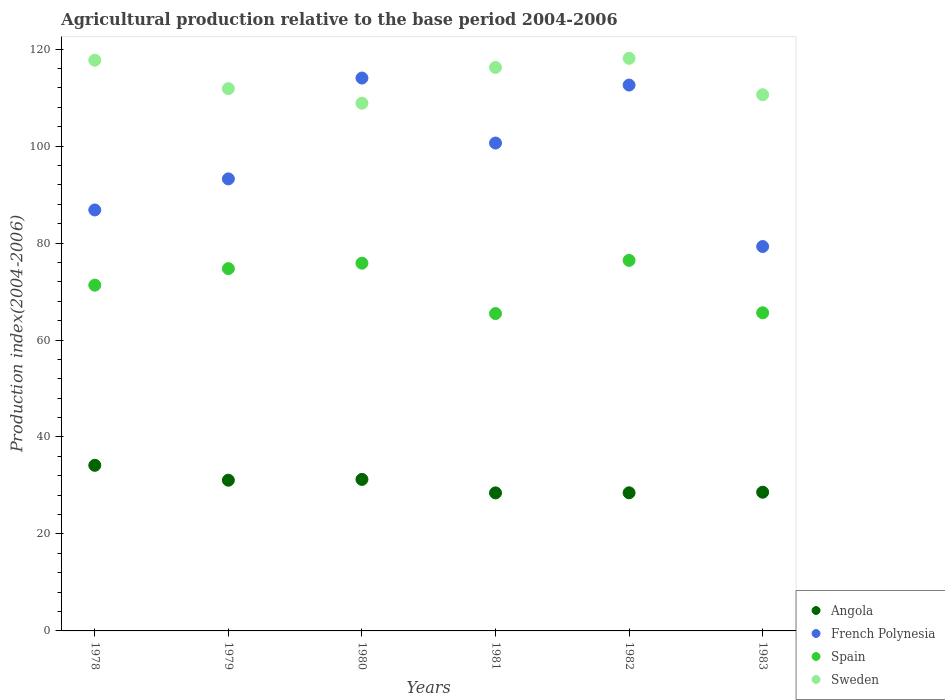Is the number of dotlines equal to the number of legend labels?
Offer a very short reply. Yes. What is the agricultural production index in Spain in 1983?
Your answer should be very brief. 65.62. Across all years, what is the maximum agricultural production index in French Polynesia?
Give a very brief answer. 114.04. Across all years, what is the minimum agricultural production index in French Polynesia?
Offer a terse response. 79.29. What is the total agricultural production index in Sweden in the graph?
Offer a terse response. 683.36. What is the difference between the agricultural production index in French Polynesia in 1978 and that in 1980?
Offer a terse response. -27.21. What is the difference between the agricultural production index in French Polynesia in 1979 and the agricultural production index in Sweden in 1981?
Make the answer very short. -22.99. What is the average agricultural production index in French Polynesia per year?
Ensure brevity in your answer.  97.77. In the year 1978, what is the difference between the agricultural production index in Angola and agricultural production index in Sweden?
Provide a succinct answer. -83.56. In how many years, is the agricultural production index in Sweden greater than 8?
Your answer should be compact. 6. What is the ratio of the agricultural production index in Sweden in 1980 to that in 1983?
Make the answer very short. 0.98. What is the difference between the highest and the second highest agricultural production index in French Polynesia?
Offer a terse response. 1.45. What is the difference between the highest and the lowest agricultural production index in Sweden?
Keep it short and to the point. 9.26. In how many years, is the agricultural production index in Angola greater than the average agricultural production index in Angola taken over all years?
Your response must be concise. 3. Does the agricultural production index in Angola monotonically increase over the years?
Your response must be concise. No. How many dotlines are there?
Keep it short and to the point. 4. How many years are there in the graph?
Ensure brevity in your answer.  6. What is the difference between two consecutive major ticks on the Y-axis?
Keep it short and to the point. 20. Does the graph contain grids?
Your answer should be very brief. No. How many legend labels are there?
Provide a short and direct response. 4. How are the legend labels stacked?
Offer a very short reply. Vertical. What is the title of the graph?
Give a very brief answer. Agricultural production relative to the base period 2004-2006. Does "South Sudan" appear as one of the legend labels in the graph?
Ensure brevity in your answer.  No. What is the label or title of the X-axis?
Give a very brief answer. Years. What is the label or title of the Y-axis?
Ensure brevity in your answer.  Production index(2004-2006). What is the Production index(2004-2006) in Angola in 1978?
Offer a very short reply. 34.16. What is the Production index(2004-2006) in French Polynesia in 1978?
Your response must be concise. 86.83. What is the Production index(2004-2006) of Spain in 1978?
Your response must be concise. 71.32. What is the Production index(2004-2006) of Sweden in 1978?
Your response must be concise. 117.72. What is the Production index(2004-2006) of Angola in 1979?
Your answer should be compact. 31.09. What is the Production index(2004-2006) of French Polynesia in 1979?
Give a very brief answer. 93.24. What is the Production index(2004-2006) of Spain in 1979?
Your response must be concise. 74.73. What is the Production index(2004-2006) of Sweden in 1979?
Keep it short and to the point. 111.85. What is the Production index(2004-2006) in Angola in 1980?
Give a very brief answer. 31.25. What is the Production index(2004-2006) of French Polynesia in 1980?
Your response must be concise. 114.04. What is the Production index(2004-2006) of Spain in 1980?
Keep it short and to the point. 75.85. What is the Production index(2004-2006) in Sweden in 1980?
Your response must be concise. 108.85. What is the Production index(2004-2006) of Angola in 1981?
Offer a terse response. 28.47. What is the Production index(2004-2006) in French Polynesia in 1981?
Make the answer very short. 100.63. What is the Production index(2004-2006) of Spain in 1981?
Give a very brief answer. 65.46. What is the Production index(2004-2006) of Sweden in 1981?
Ensure brevity in your answer.  116.23. What is the Production index(2004-2006) of Angola in 1982?
Provide a short and direct response. 28.49. What is the Production index(2004-2006) in French Polynesia in 1982?
Your answer should be compact. 112.59. What is the Production index(2004-2006) in Spain in 1982?
Provide a succinct answer. 76.43. What is the Production index(2004-2006) in Sweden in 1982?
Make the answer very short. 118.11. What is the Production index(2004-2006) in Angola in 1983?
Your response must be concise. 28.61. What is the Production index(2004-2006) of French Polynesia in 1983?
Give a very brief answer. 79.29. What is the Production index(2004-2006) of Spain in 1983?
Offer a very short reply. 65.62. What is the Production index(2004-2006) in Sweden in 1983?
Ensure brevity in your answer.  110.6. Across all years, what is the maximum Production index(2004-2006) of Angola?
Offer a very short reply. 34.16. Across all years, what is the maximum Production index(2004-2006) in French Polynesia?
Keep it short and to the point. 114.04. Across all years, what is the maximum Production index(2004-2006) in Spain?
Provide a succinct answer. 76.43. Across all years, what is the maximum Production index(2004-2006) in Sweden?
Ensure brevity in your answer.  118.11. Across all years, what is the minimum Production index(2004-2006) of Angola?
Make the answer very short. 28.47. Across all years, what is the minimum Production index(2004-2006) in French Polynesia?
Offer a very short reply. 79.29. Across all years, what is the minimum Production index(2004-2006) in Spain?
Make the answer very short. 65.46. Across all years, what is the minimum Production index(2004-2006) of Sweden?
Make the answer very short. 108.85. What is the total Production index(2004-2006) of Angola in the graph?
Give a very brief answer. 182.07. What is the total Production index(2004-2006) of French Polynesia in the graph?
Offer a very short reply. 586.62. What is the total Production index(2004-2006) of Spain in the graph?
Your response must be concise. 429.41. What is the total Production index(2004-2006) of Sweden in the graph?
Offer a very short reply. 683.36. What is the difference between the Production index(2004-2006) of Angola in 1978 and that in 1979?
Make the answer very short. 3.07. What is the difference between the Production index(2004-2006) in French Polynesia in 1978 and that in 1979?
Your response must be concise. -6.41. What is the difference between the Production index(2004-2006) in Spain in 1978 and that in 1979?
Offer a very short reply. -3.41. What is the difference between the Production index(2004-2006) of Sweden in 1978 and that in 1979?
Offer a very short reply. 5.87. What is the difference between the Production index(2004-2006) in Angola in 1978 and that in 1980?
Your response must be concise. 2.91. What is the difference between the Production index(2004-2006) in French Polynesia in 1978 and that in 1980?
Offer a terse response. -27.21. What is the difference between the Production index(2004-2006) in Spain in 1978 and that in 1980?
Give a very brief answer. -4.53. What is the difference between the Production index(2004-2006) in Sweden in 1978 and that in 1980?
Your response must be concise. 8.87. What is the difference between the Production index(2004-2006) in Angola in 1978 and that in 1981?
Keep it short and to the point. 5.69. What is the difference between the Production index(2004-2006) of French Polynesia in 1978 and that in 1981?
Provide a short and direct response. -13.8. What is the difference between the Production index(2004-2006) of Spain in 1978 and that in 1981?
Your response must be concise. 5.86. What is the difference between the Production index(2004-2006) of Sweden in 1978 and that in 1981?
Your answer should be compact. 1.49. What is the difference between the Production index(2004-2006) in Angola in 1978 and that in 1982?
Give a very brief answer. 5.67. What is the difference between the Production index(2004-2006) of French Polynesia in 1978 and that in 1982?
Ensure brevity in your answer.  -25.76. What is the difference between the Production index(2004-2006) in Spain in 1978 and that in 1982?
Provide a short and direct response. -5.11. What is the difference between the Production index(2004-2006) of Sweden in 1978 and that in 1982?
Make the answer very short. -0.39. What is the difference between the Production index(2004-2006) of Angola in 1978 and that in 1983?
Provide a succinct answer. 5.55. What is the difference between the Production index(2004-2006) of French Polynesia in 1978 and that in 1983?
Give a very brief answer. 7.54. What is the difference between the Production index(2004-2006) in Spain in 1978 and that in 1983?
Your response must be concise. 5.7. What is the difference between the Production index(2004-2006) in Sweden in 1978 and that in 1983?
Keep it short and to the point. 7.12. What is the difference between the Production index(2004-2006) of Angola in 1979 and that in 1980?
Provide a succinct answer. -0.16. What is the difference between the Production index(2004-2006) of French Polynesia in 1979 and that in 1980?
Your response must be concise. -20.8. What is the difference between the Production index(2004-2006) in Spain in 1979 and that in 1980?
Your answer should be compact. -1.12. What is the difference between the Production index(2004-2006) in Sweden in 1979 and that in 1980?
Provide a short and direct response. 3. What is the difference between the Production index(2004-2006) of Angola in 1979 and that in 1981?
Provide a succinct answer. 2.62. What is the difference between the Production index(2004-2006) in French Polynesia in 1979 and that in 1981?
Offer a very short reply. -7.39. What is the difference between the Production index(2004-2006) in Spain in 1979 and that in 1981?
Ensure brevity in your answer.  9.27. What is the difference between the Production index(2004-2006) in Sweden in 1979 and that in 1981?
Offer a very short reply. -4.38. What is the difference between the Production index(2004-2006) in Angola in 1979 and that in 1982?
Your response must be concise. 2.6. What is the difference between the Production index(2004-2006) in French Polynesia in 1979 and that in 1982?
Offer a very short reply. -19.35. What is the difference between the Production index(2004-2006) of Spain in 1979 and that in 1982?
Your answer should be very brief. -1.7. What is the difference between the Production index(2004-2006) of Sweden in 1979 and that in 1982?
Offer a terse response. -6.26. What is the difference between the Production index(2004-2006) of Angola in 1979 and that in 1983?
Provide a short and direct response. 2.48. What is the difference between the Production index(2004-2006) in French Polynesia in 1979 and that in 1983?
Your response must be concise. 13.95. What is the difference between the Production index(2004-2006) in Spain in 1979 and that in 1983?
Your response must be concise. 9.11. What is the difference between the Production index(2004-2006) in Sweden in 1979 and that in 1983?
Ensure brevity in your answer.  1.25. What is the difference between the Production index(2004-2006) of Angola in 1980 and that in 1981?
Keep it short and to the point. 2.78. What is the difference between the Production index(2004-2006) in French Polynesia in 1980 and that in 1981?
Ensure brevity in your answer.  13.41. What is the difference between the Production index(2004-2006) in Spain in 1980 and that in 1981?
Your answer should be compact. 10.39. What is the difference between the Production index(2004-2006) in Sweden in 1980 and that in 1981?
Your answer should be compact. -7.38. What is the difference between the Production index(2004-2006) of Angola in 1980 and that in 1982?
Give a very brief answer. 2.76. What is the difference between the Production index(2004-2006) of French Polynesia in 1980 and that in 1982?
Provide a short and direct response. 1.45. What is the difference between the Production index(2004-2006) of Spain in 1980 and that in 1982?
Your response must be concise. -0.58. What is the difference between the Production index(2004-2006) of Sweden in 1980 and that in 1982?
Keep it short and to the point. -9.26. What is the difference between the Production index(2004-2006) of Angola in 1980 and that in 1983?
Provide a succinct answer. 2.64. What is the difference between the Production index(2004-2006) of French Polynesia in 1980 and that in 1983?
Your response must be concise. 34.75. What is the difference between the Production index(2004-2006) in Spain in 1980 and that in 1983?
Your answer should be compact. 10.23. What is the difference between the Production index(2004-2006) in Sweden in 1980 and that in 1983?
Your answer should be very brief. -1.75. What is the difference between the Production index(2004-2006) in Angola in 1981 and that in 1982?
Keep it short and to the point. -0.02. What is the difference between the Production index(2004-2006) of French Polynesia in 1981 and that in 1982?
Provide a short and direct response. -11.96. What is the difference between the Production index(2004-2006) of Spain in 1981 and that in 1982?
Your answer should be compact. -10.97. What is the difference between the Production index(2004-2006) of Sweden in 1981 and that in 1982?
Keep it short and to the point. -1.88. What is the difference between the Production index(2004-2006) of Angola in 1981 and that in 1983?
Make the answer very short. -0.14. What is the difference between the Production index(2004-2006) in French Polynesia in 1981 and that in 1983?
Keep it short and to the point. 21.34. What is the difference between the Production index(2004-2006) in Spain in 1981 and that in 1983?
Your answer should be compact. -0.16. What is the difference between the Production index(2004-2006) of Sweden in 1981 and that in 1983?
Keep it short and to the point. 5.63. What is the difference between the Production index(2004-2006) in Angola in 1982 and that in 1983?
Your response must be concise. -0.12. What is the difference between the Production index(2004-2006) of French Polynesia in 1982 and that in 1983?
Provide a short and direct response. 33.3. What is the difference between the Production index(2004-2006) in Spain in 1982 and that in 1983?
Give a very brief answer. 10.81. What is the difference between the Production index(2004-2006) in Sweden in 1982 and that in 1983?
Offer a terse response. 7.51. What is the difference between the Production index(2004-2006) of Angola in 1978 and the Production index(2004-2006) of French Polynesia in 1979?
Give a very brief answer. -59.08. What is the difference between the Production index(2004-2006) of Angola in 1978 and the Production index(2004-2006) of Spain in 1979?
Give a very brief answer. -40.57. What is the difference between the Production index(2004-2006) of Angola in 1978 and the Production index(2004-2006) of Sweden in 1979?
Your answer should be compact. -77.69. What is the difference between the Production index(2004-2006) in French Polynesia in 1978 and the Production index(2004-2006) in Sweden in 1979?
Ensure brevity in your answer.  -25.02. What is the difference between the Production index(2004-2006) in Spain in 1978 and the Production index(2004-2006) in Sweden in 1979?
Your answer should be compact. -40.53. What is the difference between the Production index(2004-2006) in Angola in 1978 and the Production index(2004-2006) in French Polynesia in 1980?
Ensure brevity in your answer.  -79.88. What is the difference between the Production index(2004-2006) of Angola in 1978 and the Production index(2004-2006) of Spain in 1980?
Provide a succinct answer. -41.69. What is the difference between the Production index(2004-2006) in Angola in 1978 and the Production index(2004-2006) in Sweden in 1980?
Your answer should be very brief. -74.69. What is the difference between the Production index(2004-2006) in French Polynesia in 1978 and the Production index(2004-2006) in Spain in 1980?
Provide a short and direct response. 10.98. What is the difference between the Production index(2004-2006) in French Polynesia in 1978 and the Production index(2004-2006) in Sweden in 1980?
Offer a very short reply. -22.02. What is the difference between the Production index(2004-2006) of Spain in 1978 and the Production index(2004-2006) of Sweden in 1980?
Your answer should be very brief. -37.53. What is the difference between the Production index(2004-2006) of Angola in 1978 and the Production index(2004-2006) of French Polynesia in 1981?
Your answer should be compact. -66.47. What is the difference between the Production index(2004-2006) of Angola in 1978 and the Production index(2004-2006) of Spain in 1981?
Offer a terse response. -31.3. What is the difference between the Production index(2004-2006) of Angola in 1978 and the Production index(2004-2006) of Sweden in 1981?
Provide a succinct answer. -82.07. What is the difference between the Production index(2004-2006) in French Polynesia in 1978 and the Production index(2004-2006) in Spain in 1981?
Keep it short and to the point. 21.37. What is the difference between the Production index(2004-2006) in French Polynesia in 1978 and the Production index(2004-2006) in Sweden in 1981?
Offer a very short reply. -29.4. What is the difference between the Production index(2004-2006) in Spain in 1978 and the Production index(2004-2006) in Sweden in 1981?
Your answer should be very brief. -44.91. What is the difference between the Production index(2004-2006) in Angola in 1978 and the Production index(2004-2006) in French Polynesia in 1982?
Provide a short and direct response. -78.43. What is the difference between the Production index(2004-2006) in Angola in 1978 and the Production index(2004-2006) in Spain in 1982?
Offer a terse response. -42.27. What is the difference between the Production index(2004-2006) of Angola in 1978 and the Production index(2004-2006) of Sweden in 1982?
Your response must be concise. -83.95. What is the difference between the Production index(2004-2006) in French Polynesia in 1978 and the Production index(2004-2006) in Spain in 1982?
Offer a very short reply. 10.4. What is the difference between the Production index(2004-2006) in French Polynesia in 1978 and the Production index(2004-2006) in Sweden in 1982?
Your answer should be very brief. -31.28. What is the difference between the Production index(2004-2006) of Spain in 1978 and the Production index(2004-2006) of Sweden in 1982?
Keep it short and to the point. -46.79. What is the difference between the Production index(2004-2006) of Angola in 1978 and the Production index(2004-2006) of French Polynesia in 1983?
Offer a very short reply. -45.13. What is the difference between the Production index(2004-2006) in Angola in 1978 and the Production index(2004-2006) in Spain in 1983?
Provide a short and direct response. -31.46. What is the difference between the Production index(2004-2006) of Angola in 1978 and the Production index(2004-2006) of Sweden in 1983?
Offer a terse response. -76.44. What is the difference between the Production index(2004-2006) of French Polynesia in 1978 and the Production index(2004-2006) of Spain in 1983?
Your answer should be compact. 21.21. What is the difference between the Production index(2004-2006) in French Polynesia in 1978 and the Production index(2004-2006) in Sweden in 1983?
Your answer should be compact. -23.77. What is the difference between the Production index(2004-2006) in Spain in 1978 and the Production index(2004-2006) in Sweden in 1983?
Your response must be concise. -39.28. What is the difference between the Production index(2004-2006) of Angola in 1979 and the Production index(2004-2006) of French Polynesia in 1980?
Offer a very short reply. -82.95. What is the difference between the Production index(2004-2006) of Angola in 1979 and the Production index(2004-2006) of Spain in 1980?
Keep it short and to the point. -44.76. What is the difference between the Production index(2004-2006) of Angola in 1979 and the Production index(2004-2006) of Sweden in 1980?
Ensure brevity in your answer.  -77.76. What is the difference between the Production index(2004-2006) of French Polynesia in 1979 and the Production index(2004-2006) of Spain in 1980?
Make the answer very short. 17.39. What is the difference between the Production index(2004-2006) in French Polynesia in 1979 and the Production index(2004-2006) in Sweden in 1980?
Your answer should be compact. -15.61. What is the difference between the Production index(2004-2006) in Spain in 1979 and the Production index(2004-2006) in Sweden in 1980?
Offer a terse response. -34.12. What is the difference between the Production index(2004-2006) of Angola in 1979 and the Production index(2004-2006) of French Polynesia in 1981?
Your response must be concise. -69.54. What is the difference between the Production index(2004-2006) in Angola in 1979 and the Production index(2004-2006) in Spain in 1981?
Ensure brevity in your answer.  -34.37. What is the difference between the Production index(2004-2006) of Angola in 1979 and the Production index(2004-2006) of Sweden in 1981?
Your answer should be very brief. -85.14. What is the difference between the Production index(2004-2006) of French Polynesia in 1979 and the Production index(2004-2006) of Spain in 1981?
Your answer should be very brief. 27.78. What is the difference between the Production index(2004-2006) in French Polynesia in 1979 and the Production index(2004-2006) in Sweden in 1981?
Keep it short and to the point. -22.99. What is the difference between the Production index(2004-2006) in Spain in 1979 and the Production index(2004-2006) in Sweden in 1981?
Give a very brief answer. -41.5. What is the difference between the Production index(2004-2006) in Angola in 1979 and the Production index(2004-2006) in French Polynesia in 1982?
Make the answer very short. -81.5. What is the difference between the Production index(2004-2006) of Angola in 1979 and the Production index(2004-2006) of Spain in 1982?
Keep it short and to the point. -45.34. What is the difference between the Production index(2004-2006) of Angola in 1979 and the Production index(2004-2006) of Sweden in 1982?
Your answer should be compact. -87.02. What is the difference between the Production index(2004-2006) in French Polynesia in 1979 and the Production index(2004-2006) in Spain in 1982?
Your answer should be compact. 16.81. What is the difference between the Production index(2004-2006) in French Polynesia in 1979 and the Production index(2004-2006) in Sweden in 1982?
Make the answer very short. -24.87. What is the difference between the Production index(2004-2006) in Spain in 1979 and the Production index(2004-2006) in Sweden in 1982?
Offer a terse response. -43.38. What is the difference between the Production index(2004-2006) in Angola in 1979 and the Production index(2004-2006) in French Polynesia in 1983?
Your answer should be compact. -48.2. What is the difference between the Production index(2004-2006) of Angola in 1979 and the Production index(2004-2006) of Spain in 1983?
Your answer should be compact. -34.53. What is the difference between the Production index(2004-2006) in Angola in 1979 and the Production index(2004-2006) in Sweden in 1983?
Ensure brevity in your answer.  -79.51. What is the difference between the Production index(2004-2006) of French Polynesia in 1979 and the Production index(2004-2006) of Spain in 1983?
Provide a succinct answer. 27.62. What is the difference between the Production index(2004-2006) of French Polynesia in 1979 and the Production index(2004-2006) of Sweden in 1983?
Your answer should be compact. -17.36. What is the difference between the Production index(2004-2006) in Spain in 1979 and the Production index(2004-2006) in Sweden in 1983?
Your response must be concise. -35.87. What is the difference between the Production index(2004-2006) of Angola in 1980 and the Production index(2004-2006) of French Polynesia in 1981?
Give a very brief answer. -69.38. What is the difference between the Production index(2004-2006) in Angola in 1980 and the Production index(2004-2006) in Spain in 1981?
Offer a very short reply. -34.21. What is the difference between the Production index(2004-2006) of Angola in 1980 and the Production index(2004-2006) of Sweden in 1981?
Make the answer very short. -84.98. What is the difference between the Production index(2004-2006) of French Polynesia in 1980 and the Production index(2004-2006) of Spain in 1981?
Offer a terse response. 48.58. What is the difference between the Production index(2004-2006) in French Polynesia in 1980 and the Production index(2004-2006) in Sweden in 1981?
Provide a succinct answer. -2.19. What is the difference between the Production index(2004-2006) in Spain in 1980 and the Production index(2004-2006) in Sweden in 1981?
Your answer should be compact. -40.38. What is the difference between the Production index(2004-2006) of Angola in 1980 and the Production index(2004-2006) of French Polynesia in 1982?
Offer a very short reply. -81.34. What is the difference between the Production index(2004-2006) in Angola in 1980 and the Production index(2004-2006) in Spain in 1982?
Keep it short and to the point. -45.18. What is the difference between the Production index(2004-2006) of Angola in 1980 and the Production index(2004-2006) of Sweden in 1982?
Offer a terse response. -86.86. What is the difference between the Production index(2004-2006) in French Polynesia in 1980 and the Production index(2004-2006) in Spain in 1982?
Offer a very short reply. 37.61. What is the difference between the Production index(2004-2006) in French Polynesia in 1980 and the Production index(2004-2006) in Sweden in 1982?
Keep it short and to the point. -4.07. What is the difference between the Production index(2004-2006) of Spain in 1980 and the Production index(2004-2006) of Sweden in 1982?
Make the answer very short. -42.26. What is the difference between the Production index(2004-2006) of Angola in 1980 and the Production index(2004-2006) of French Polynesia in 1983?
Provide a succinct answer. -48.04. What is the difference between the Production index(2004-2006) of Angola in 1980 and the Production index(2004-2006) of Spain in 1983?
Your answer should be compact. -34.37. What is the difference between the Production index(2004-2006) of Angola in 1980 and the Production index(2004-2006) of Sweden in 1983?
Ensure brevity in your answer.  -79.35. What is the difference between the Production index(2004-2006) in French Polynesia in 1980 and the Production index(2004-2006) in Spain in 1983?
Offer a terse response. 48.42. What is the difference between the Production index(2004-2006) of French Polynesia in 1980 and the Production index(2004-2006) of Sweden in 1983?
Provide a succinct answer. 3.44. What is the difference between the Production index(2004-2006) of Spain in 1980 and the Production index(2004-2006) of Sweden in 1983?
Ensure brevity in your answer.  -34.75. What is the difference between the Production index(2004-2006) in Angola in 1981 and the Production index(2004-2006) in French Polynesia in 1982?
Keep it short and to the point. -84.12. What is the difference between the Production index(2004-2006) of Angola in 1981 and the Production index(2004-2006) of Spain in 1982?
Offer a very short reply. -47.96. What is the difference between the Production index(2004-2006) of Angola in 1981 and the Production index(2004-2006) of Sweden in 1982?
Give a very brief answer. -89.64. What is the difference between the Production index(2004-2006) of French Polynesia in 1981 and the Production index(2004-2006) of Spain in 1982?
Offer a very short reply. 24.2. What is the difference between the Production index(2004-2006) of French Polynesia in 1981 and the Production index(2004-2006) of Sweden in 1982?
Your response must be concise. -17.48. What is the difference between the Production index(2004-2006) in Spain in 1981 and the Production index(2004-2006) in Sweden in 1982?
Your response must be concise. -52.65. What is the difference between the Production index(2004-2006) of Angola in 1981 and the Production index(2004-2006) of French Polynesia in 1983?
Offer a very short reply. -50.82. What is the difference between the Production index(2004-2006) of Angola in 1981 and the Production index(2004-2006) of Spain in 1983?
Give a very brief answer. -37.15. What is the difference between the Production index(2004-2006) of Angola in 1981 and the Production index(2004-2006) of Sweden in 1983?
Provide a succinct answer. -82.13. What is the difference between the Production index(2004-2006) in French Polynesia in 1981 and the Production index(2004-2006) in Spain in 1983?
Provide a succinct answer. 35.01. What is the difference between the Production index(2004-2006) in French Polynesia in 1981 and the Production index(2004-2006) in Sweden in 1983?
Give a very brief answer. -9.97. What is the difference between the Production index(2004-2006) in Spain in 1981 and the Production index(2004-2006) in Sweden in 1983?
Ensure brevity in your answer.  -45.14. What is the difference between the Production index(2004-2006) in Angola in 1982 and the Production index(2004-2006) in French Polynesia in 1983?
Provide a succinct answer. -50.8. What is the difference between the Production index(2004-2006) of Angola in 1982 and the Production index(2004-2006) of Spain in 1983?
Your answer should be very brief. -37.13. What is the difference between the Production index(2004-2006) in Angola in 1982 and the Production index(2004-2006) in Sweden in 1983?
Your answer should be very brief. -82.11. What is the difference between the Production index(2004-2006) in French Polynesia in 1982 and the Production index(2004-2006) in Spain in 1983?
Provide a short and direct response. 46.97. What is the difference between the Production index(2004-2006) in French Polynesia in 1982 and the Production index(2004-2006) in Sweden in 1983?
Your response must be concise. 1.99. What is the difference between the Production index(2004-2006) of Spain in 1982 and the Production index(2004-2006) of Sweden in 1983?
Give a very brief answer. -34.17. What is the average Production index(2004-2006) in Angola per year?
Provide a short and direct response. 30.34. What is the average Production index(2004-2006) in French Polynesia per year?
Offer a terse response. 97.77. What is the average Production index(2004-2006) in Spain per year?
Your answer should be compact. 71.57. What is the average Production index(2004-2006) in Sweden per year?
Offer a terse response. 113.89. In the year 1978, what is the difference between the Production index(2004-2006) in Angola and Production index(2004-2006) in French Polynesia?
Your answer should be compact. -52.67. In the year 1978, what is the difference between the Production index(2004-2006) of Angola and Production index(2004-2006) of Spain?
Make the answer very short. -37.16. In the year 1978, what is the difference between the Production index(2004-2006) of Angola and Production index(2004-2006) of Sweden?
Keep it short and to the point. -83.56. In the year 1978, what is the difference between the Production index(2004-2006) in French Polynesia and Production index(2004-2006) in Spain?
Offer a very short reply. 15.51. In the year 1978, what is the difference between the Production index(2004-2006) of French Polynesia and Production index(2004-2006) of Sweden?
Your answer should be very brief. -30.89. In the year 1978, what is the difference between the Production index(2004-2006) in Spain and Production index(2004-2006) in Sweden?
Your answer should be very brief. -46.4. In the year 1979, what is the difference between the Production index(2004-2006) of Angola and Production index(2004-2006) of French Polynesia?
Keep it short and to the point. -62.15. In the year 1979, what is the difference between the Production index(2004-2006) in Angola and Production index(2004-2006) in Spain?
Give a very brief answer. -43.64. In the year 1979, what is the difference between the Production index(2004-2006) in Angola and Production index(2004-2006) in Sweden?
Your answer should be compact. -80.76. In the year 1979, what is the difference between the Production index(2004-2006) of French Polynesia and Production index(2004-2006) of Spain?
Keep it short and to the point. 18.51. In the year 1979, what is the difference between the Production index(2004-2006) of French Polynesia and Production index(2004-2006) of Sweden?
Offer a terse response. -18.61. In the year 1979, what is the difference between the Production index(2004-2006) of Spain and Production index(2004-2006) of Sweden?
Keep it short and to the point. -37.12. In the year 1980, what is the difference between the Production index(2004-2006) of Angola and Production index(2004-2006) of French Polynesia?
Your answer should be compact. -82.79. In the year 1980, what is the difference between the Production index(2004-2006) of Angola and Production index(2004-2006) of Spain?
Your answer should be compact. -44.6. In the year 1980, what is the difference between the Production index(2004-2006) in Angola and Production index(2004-2006) in Sweden?
Provide a succinct answer. -77.6. In the year 1980, what is the difference between the Production index(2004-2006) of French Polynesia and Production index(2004-2006) of Spain?
Your answer should be compact. 38.19. In the year 1980, what is the difference between the Production index(2004-2006) in French Polynesia and Production index(2004-2006) in Sweden?
Provide a short and direct response. 5.19. In the year 1980, what is the difference between the Production index(2004-2006) in Spain and Production index(2004-2006) in Sweden?
Offer a terse response. -33. In the year 1981, what is the difference between the Production index(2004-2006) of Angola and Production index(2004-2006) of French Polynesia?
Your answer should be compact. -72.16. In the year 1981, what is the difference between the Production index(2004-2006) in Angola and Production index(2004-2006) in Spain?
Make the answer very short. -36.99. In the year 1981, what is the difference between the Production index(2004-2006) of Angola and Production index(2004-2006) of Sweden?
Ensure brevity in your answer.  -87.76. In the year 1981, what is the difference between the Production index(2004-2006) of French Polynesia and Production index(2004-2006) of Spain?
Offer a very short reply. 35.17. In the year 1981, what is the difference between the Production index(2004-2006) in French Polynesia and Production index(2004-2006) in Sweden?
Your answer should be very brief. -15.6. In the year 1981, what is the difference between the Production index(2004-2006) of Spain and Production index(2004-2006) of Sweden?
Your answer should be compact. -50.77. In the year 1982, what is the difference between the Production index(2004-2006) of Angola and Production index(2004-2006) of French Polynesia?
Your response must be concise. -84.1. In the year 1982, what is the difference between the Production index(2004-2006) of Angola and Production index(2004-2006) of Spain?
Your response must be concise. -47.94. In the year 1982, what is the difference between the Production index(2004-2006) in Angola and Production index(2004-2006) in Sweden?
Your answer should be very brief. -89.62. In the year 1982, what is the difference between the Production index(2004-2006) in French Polynesia and Production index(2004-2006) in Spain?
Give a very brief answer. 36.16. In the year 1982, what is the difference between the Production index(2004-2006) of French Polynesia and Production index(2004-2006) of Sweden?
Offer a very short reply. -5.52. In the year 1982, what is the difference between the Production index(2004-2006) of Spain and Production index(2004-2006) of Sweden?
Ensure brevity in your answer.  -41.68. In the year 1983, what is the difference between the Production index(2004-2006) of Angola and Production index(2004-2006) of French Polynesia?
Your answer should be compact. -50.68. In the year 1983, what is the difference between the Production index(2004-2006) of Angola and Production index(2004-2006) of Spain?
Offer a very short reply. -37.01. In the year 1983, what is the difference between the Production index(2004-2006) of Angola and Production index(2004-2006) of Sweden?
Your response must be concise. -81.99. In the year 1983, what is the difference between the Production index(2004-2006) of French Polynesia and Production index(2004-2006) of Spain?
Your answer should be compact. 13.67. In the year 1983, what is the difference between the Production index(2004-2006) of French Polynesia and Production index(2004-2006) of Sweden?
Provide a short and direct response. -31.31. In the year 1983, what is the difference between the Production index(2004-2006) in Spain and Production index(2004-2006) in Sweden?
Keep it short and to the point. -44.98. What is the ratio of the Production index(2004-2006) in Angola in 1978 to that in 1979?
Your answer should be very brief. 1.1. What is the ratio of the Production index(2004-2006) in French Polynesia in 1978 to that in 1979?
Provide a succinct answer. 0.93. What is the ratio of the Production index(2004-2006) of Spain in 1978 to that in 1979?
Your answer should be compact. 0.95. What is the ratio of the Production index(2004-2006) in Sweden in 1978 to that in 1979?
Ensure brevity in your answer.  1.05. What is the ratio of the Production index(2004-2006) of Angola in 1978 to that in 1980?
Your response must be concise. 1.09. What is the ratio of the Production index(2004-2006) in French Polynesia in 1978 to that in 1980?
Your response must be concise. 0.76. What is the ratio of the Production index(2004-2006) of Spain in 1978 to that in 1980?
Provide a short and direct response. 0.94. What is the ratio of the Production index(2004-2006) of Sweden in 1978 to that in 1980?
Your response must be concise. 1.08. What is the ratio of the Production index(2004-2006) of Angola in 1978 to that in 1981?
Keep it short and to the point. 1.2. What is the ratio of the Production index(2004-2006) of French Polynesia in 1978 to that in 1981?
Ensure brevity in your answer.  0.86. What is the ratio of the Production index(2004-2006) in Spain in 1978 to that in 1981?
Provide a short and direct response. 1.09. What is the ratio of the Production index(2004-2006) of Sweden in 1978 to that in 1981?
Offer a very short reply. 1.01. What is the ratio of the Production index(2004-2006) in Angola in 1978 to that in 1982?
Provide a succinct answer. 1.2. What is the ratio of the Production index(2004-2006) in French Polynesia in 1978 to that in 1982?
Ensure brevity in your answer.  0.77. What is the ratio of the Production index(2004-2006) of Spain in 1978 to that in 1982?
Your answer should be very brief. 0.93. What is the ratio of the Production index(2004-2006) of Sweden in 1978 to that in 1982?
Your answer should be compact. 1. What is the ratio of the Production index(2004-2006) of Angola in 1978 to that in 1983?
Provide a short and direct response. 1.19. What is the ratio of the Production index(2004-2006) in French Polynesia in 1978 to that in 1983?
Your answer should be compact. 1.1. What is the ratio of the Production index(2004-2006) of Spain in 1978 to that in 1983?
Give a very brief answer. 1.09. What is the ratio of the Production index(2004-2006) in Sweden in 1978 to that in 1983?
Your answer should be very brief. 1.06. What is the ratio of the Production index(2004-2006) in French Polynesia in 1979 to that in 1980?
Your answer should be very brief. 0.82. What is the ratio of the Production index(2004-2006) of Spain in 1979 to that in 1980?
Make the answer very short. 0.99. What is the ratio of the Production index(2004-2006) in Sweden in 1979 to that in 1980?
Make the answer very short. 1.03. What is the ratio of the Production index(2004-2006) in Angola in 1979 to that in 1981?
Provide a succinct answer. 1.09. What is the ratio of the Production index(2004-2006) of French Polynesia in 1979 to that in 1981?
Provide a short and direct response. 0.93. What is the ratio of the Production index(2004-2006) of Spain in 1979 to that in 1981?
Provide a succinct answer. 1.14. What is the ratio of the Production index(2004-2006) of Sweden in 1979 to that in 1981?
Give a very brief answer. 0.96. What is the ratio of the Production index(2004-2006) of Angola in 1979 to that in 1982?
Provide a succinct answer. 1.09. What is the ratio of the Production index(2004-2006) of French Polynesia in 1979 to that in 1982?
Ensure brevity in your answer.  0.83. What is the ratio of the Production index(2004-2006) in Spain in 1979 to that in 1982?
Your answer should be compact. 0.98. What is the ratio of the Production index(2004-2006) of Sweden in 1979 to that in 1982?
Give a very brief answer. 0.95. What is the ratio of the Production index(2004-2006) in Angola in 1979 to that in 1983?
Keep it short and to the point. 1.09. What is the ratio of the Production index(2004-2006) in French Polynesia in 1979 to that in 1983?
Keep it short and to the point. 1.18. What is the ratio of the Production index(2004-2006) of Spain in 1979 to that in 1983?
Keep it short and to the point. 1.14. What is the ratio of the Production index(2004-2006) of Sweden in 1979 to that in 1983?
Give a very brief answer. 1.01. What is the ratio of the Production index(2004-2006) of Angola in 1980 to that in 1981?
Offer a terse response. 1.1. What is the ratio of the Production index(2004-2006) of French Polynesia in 1980 to that in 1981?
Provide a short and direct response. 1.13. What is the ratio of the Production index(2004-2006) in Spain in 1980 to that in 1981?
Your response must be concise. 1.16. What is the ratio of the Production index(2004-2006) in Sweden in 1980 to that in 1981?
Make the answer very short. 0.94. What is the ratio of the Production index(2004-2006) in Angola in 1980 to that in 1982?
Make the answer very short. 1.1. What is the ratio of the Production index(2004-2006) in French Polynesia in 1980 to that in 1982?
Give a very brief answer. 1.01. What is the ratio of the Production index(2004-2006) of Sweden in 1980 to that in 1982?
Your answer should be compact. 0.92. What is the ratio of the Production index(2004-2006) in Angola in 1980 to that in 1983?
Provide a succinct answer. 1.09. What is the ratio of the Production index(2004-2006) in French Polynesia in 1980 to that in 1983?
Ensure brevity in your answer.  1.44. What is the ratio of the Production index(2004-2006) of Spain in 1980 to that in 1983?
Offer a very short reply. 1.16. What is the ratio of the Production index(2004-2006) in Sweden in 1980 to that in 1983?
Give a very brief answer. 0.98. What is the ratio of the Production index(2004-2006) in French Polynesia in 1981 to that in 1982?
Provide a succinct answer. 0.89. What is the ratio of the Production index(2004-2006) in Spain in 1981 to that in 1982?
Offer a very short reply. 0.86. What is the ratio of the Production index(2004-2006) of Sweden in 1981 to that in 1982?
Offer a very short reply. 0.98. What is the ratio of the Production index(2004-2006) of Angola in 1981 to that in 1983?
Your answer should be very brief. 1. What is the ratio of the Production index(2004-2006) of French Polynesia in 1981 to that in 1983?
Provide a short and direct response. 1.27. What is the ratio of the Production index(2004-2006) of Spain in 1981 to that in 1983?
Make the answer very short. 1. What is the ratio of the Production index(2004-2006) in Sweden in 1981 to that in 1983?
Give a very brief answer. 1.05. What is the ratio of the Production index(2004-2006) in French Polynesia in 1982 to that in 1983?
Provide a succinct answer. 1.42. What is the ratio of the Production index(2004-2006) of Spain in 1982 to that in 1983?
Your answer should be very brief. 1.16. What is the ratio of the Production index(2004-2006) in Sweden in 1982 to that in 1983?
Offer a terse response. 1.07. What is the difference between the highest and the second highest Production index(2004-2006) of Angola?
Your answer should be very brief. 2.91. What is the difference between the highest and the second highest Production index(2004-2006) in French Polynesia?
Provide a succinct answer. 1.45. What is the difference between the highest and the second highest Production index(2004-2006) in Spain?
Provide a succinct answer. 0.58. What is the difference between the highest and the second highest Production index(2004-2006) of Sweden?
Keep it short and to the point. 0.39. What is the difference between the highest and the lowest Production index(2004-2006) in Angola?
Ensure brevity in your answer.  5.69. What is the difference between the highest and the lowest Production index(2004-2006) of French Polynesia?
Your answer should be very brief. 34.75. What is the difference between the highest and the lowest Production index(2004-2006) in Spain?
Make the answer very short. 10.97. What is the difference between the highest and the lowest Production index(2004-2006) of Sweden?
Offer a very short reply. 9.26. 